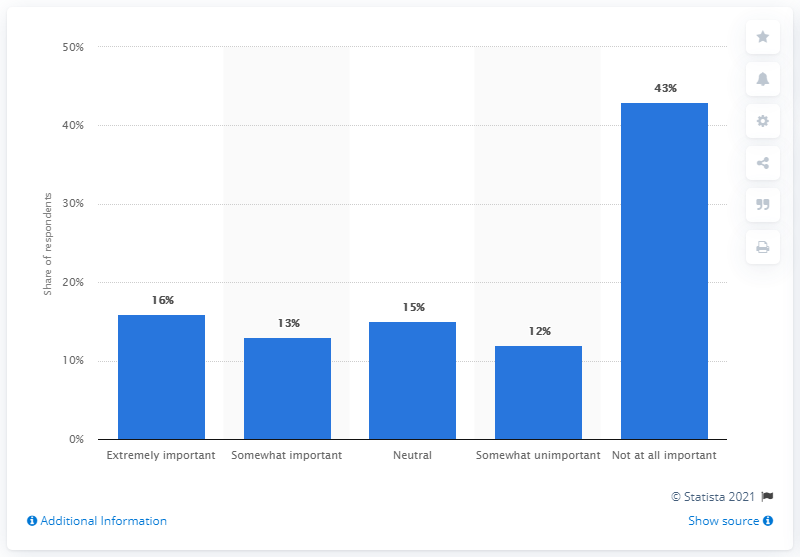Specify some key components in this picture. In the survey, 43% of respondents stated that athlete/celebrity sponsorship was not important to their decision to purchase a product or service. 